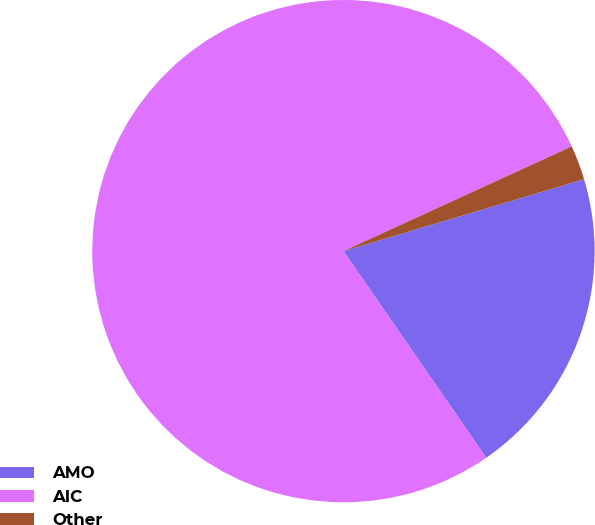Convert chart. <chart><loc_0><loc_0><loc_500><loc_500><pie_chart><fcel>AMO<fcel>AIC<fcel>Other<nl><fcel>20.0%<fcel>77.78%<fcel>2.22%<nl></chart> 